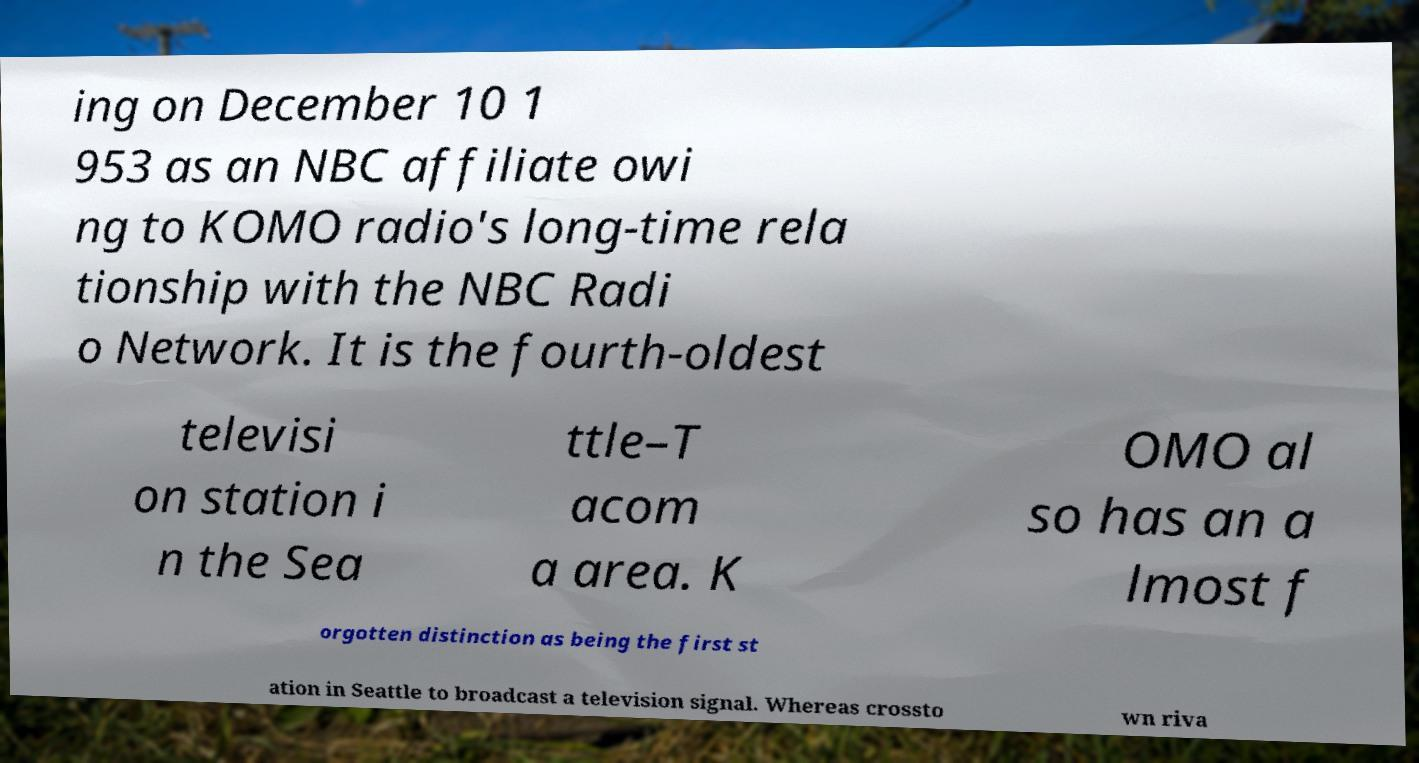Could you extract and type out the text from this image? ing on December 10 1 953 as an NBC affiliate owi ng to KOMO radio's long-time rela tionship with the NBC Radi o Network. It is the fourth-oldest televisi on station i n the Sea ttle–T acom a area. K OMO al so has an a lmost f orgotten distinction as being the first st ation in Seattle to broadcast a television signal. Whereas crossto wn riva 